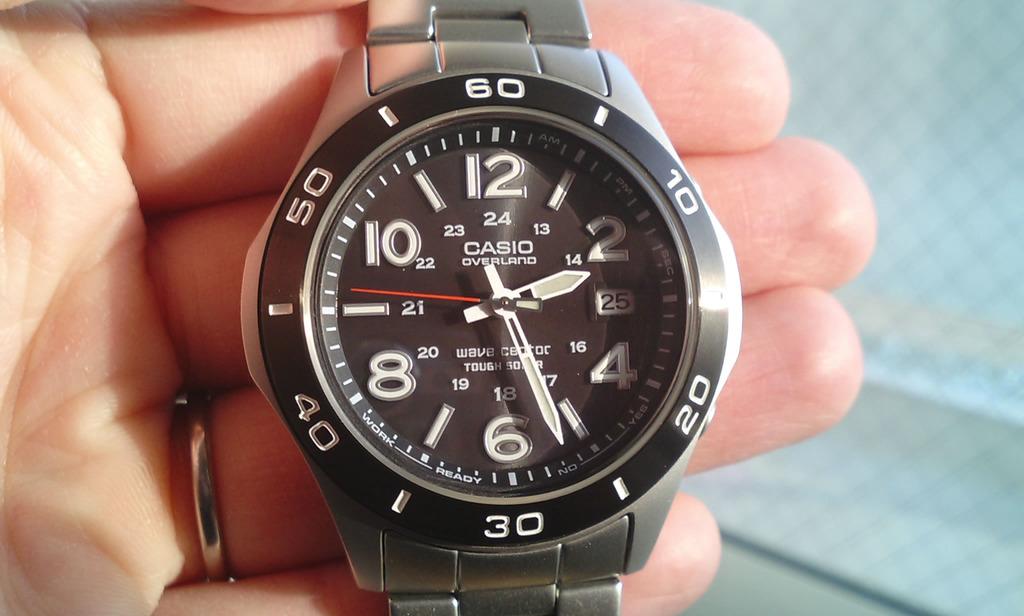What brand of watch?
Keep it short and to the point. Casio. What brand of watch?
Your answer should be compact. Casio. 